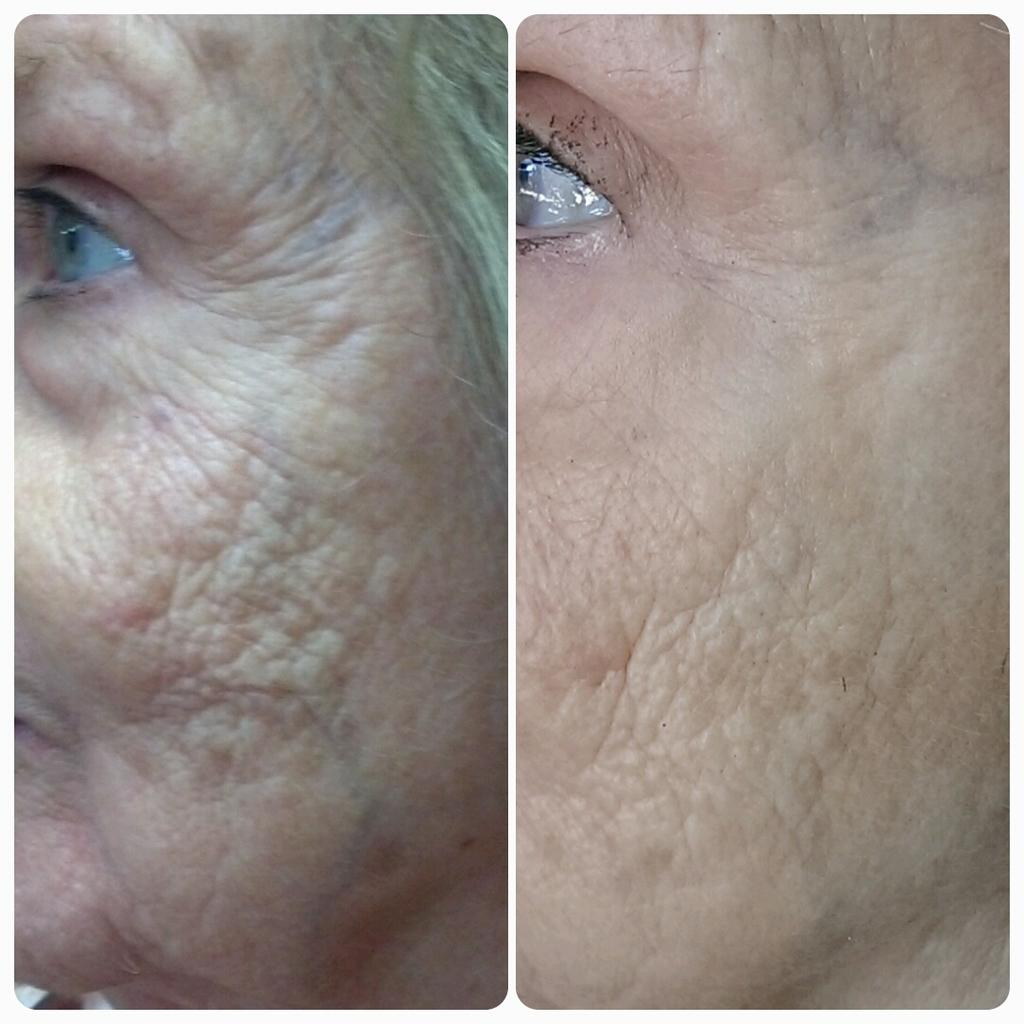What type of image is being described? The image is a collage. What can be seen in the collage? There is a close view of a person and a side view of a person in the image. What physical features are visible in the image? Wrinkles and eyes are visible in the image. How many donkeys are visible in the image? There are no donkeys present in the image. What type of mice can be seen interacting with the person in the image? There are no mice present in the image; only the person and their features are visible. 